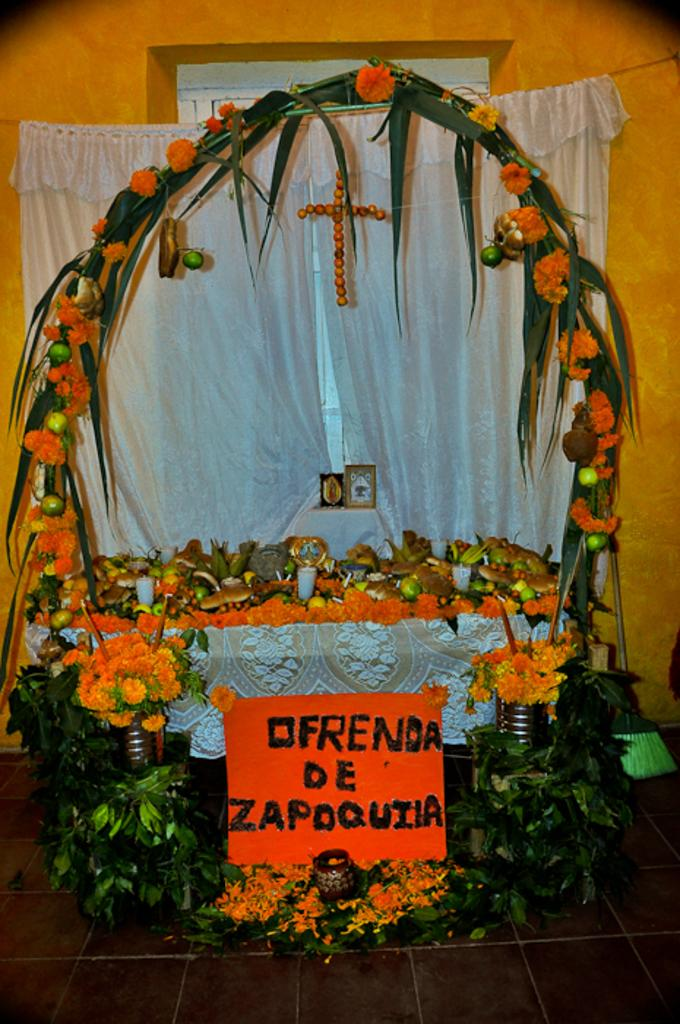What type of plants can be seen in the image? There are flowers in the image. What is located at the bottom of the image? There is a board at the bottom of the image. What type of window treatment is present in the image? There is a white color curtain in the image. What can be seen in the background of the image? There is a wall in the background of the image. What type of jam is being spread on the tramp in the image? There is no tramp or jam present in the image. 